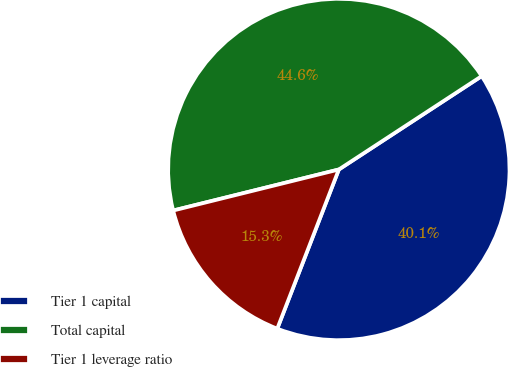Convert chart to OTSL. <chart><loc_0><loc_0><loc_500><loc_500><pie_chart><fcel>Tier 1 capital<fcel>Total capital<fcel>Tier 1 leverage ratio<nl><fcel>40.09%<fcel>44.65%<fcel>15.26%<nl></chart> 